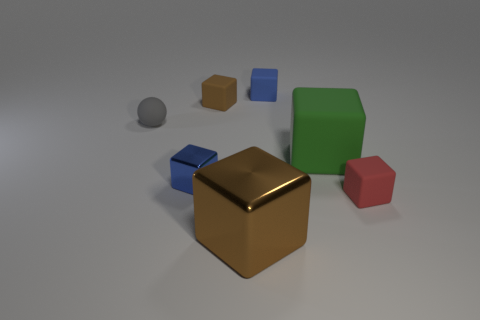Is there any other thing that has the same shape as the gray thing?
Give a very brief answer. No. Are there any other things that are the same color as the tiny matte ball?
Provide a short and direct response. No. How big is the cube that is behind the brown rubber block?
Your answer should be compact. Small. What material is the tiny red block?
Keep it short and to the point. Rubber. There is a matte object to the left of the brown thing left of the big brown shiny object; what is its shape?
Ensure brevity in your answer.  Sphere. How many other objects are there of the same shape as the small blue matte object?
Offer a terse response. 5. There is a red matte cube; are there any things behind it?
Ensure brevity in your answer.  Yes. The large matte cube has what color?
Your response must be concise. Green. There is a big metal block; is it the same color as the small object to the right of the green rubber block?
Offer a terse response. No. Is there a blue shiny block of the same size as the brown matte cube?
Your response must be concise. Yes. 